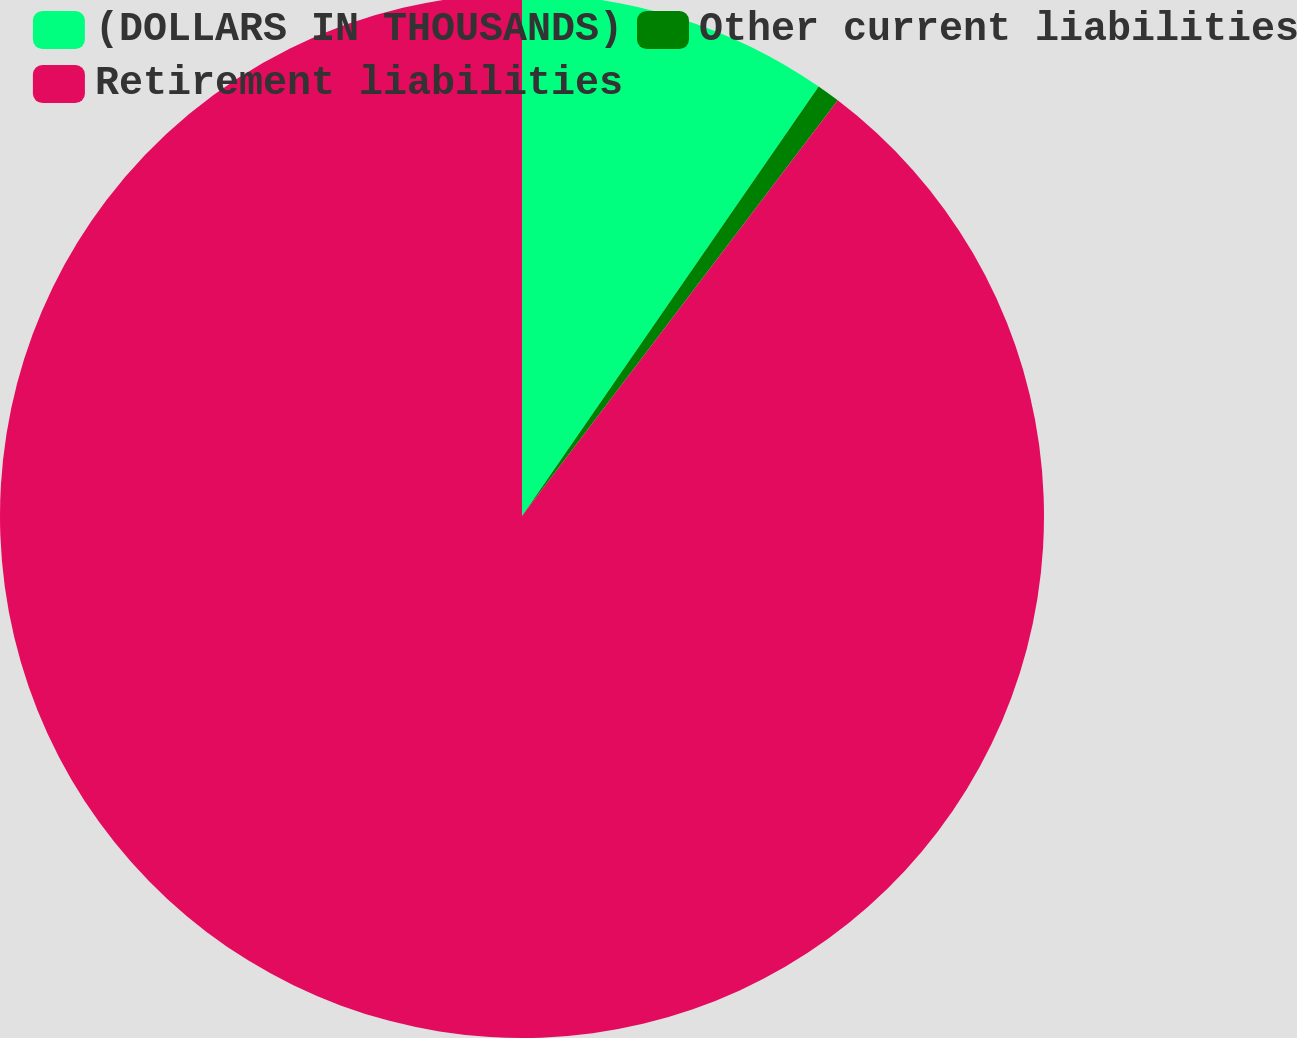Convert chart. <chart><loc_0><loc_0><loc_500><loc_500><pie_chart><fcel>(DOLLARS IN THOUSANDS)<fcel>Other current liabilities<fcel>Retirement liabilities<nl><fcel>9.62%<fcel>0.72%<fcel>89.66%<nl></chart> 